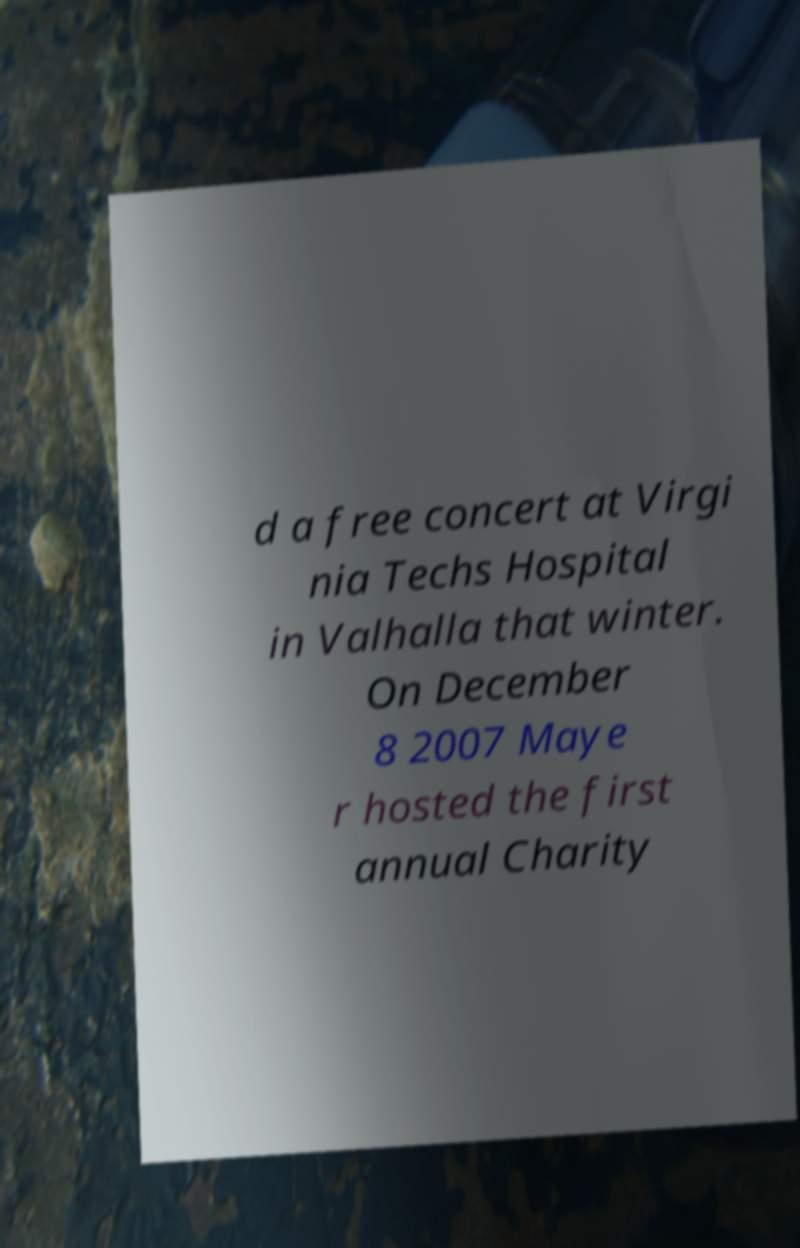For documentation purposes, I need the text within this image transcribed. Could you provide that? d a free concert at Virgi nia Techs Hospital in Valhalla that winter. On December 8 2007 Maye r hosted the first annual Charity 